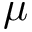<formula> <loc_0><loc_0><loc_500><loc_500>\mu</formula> 